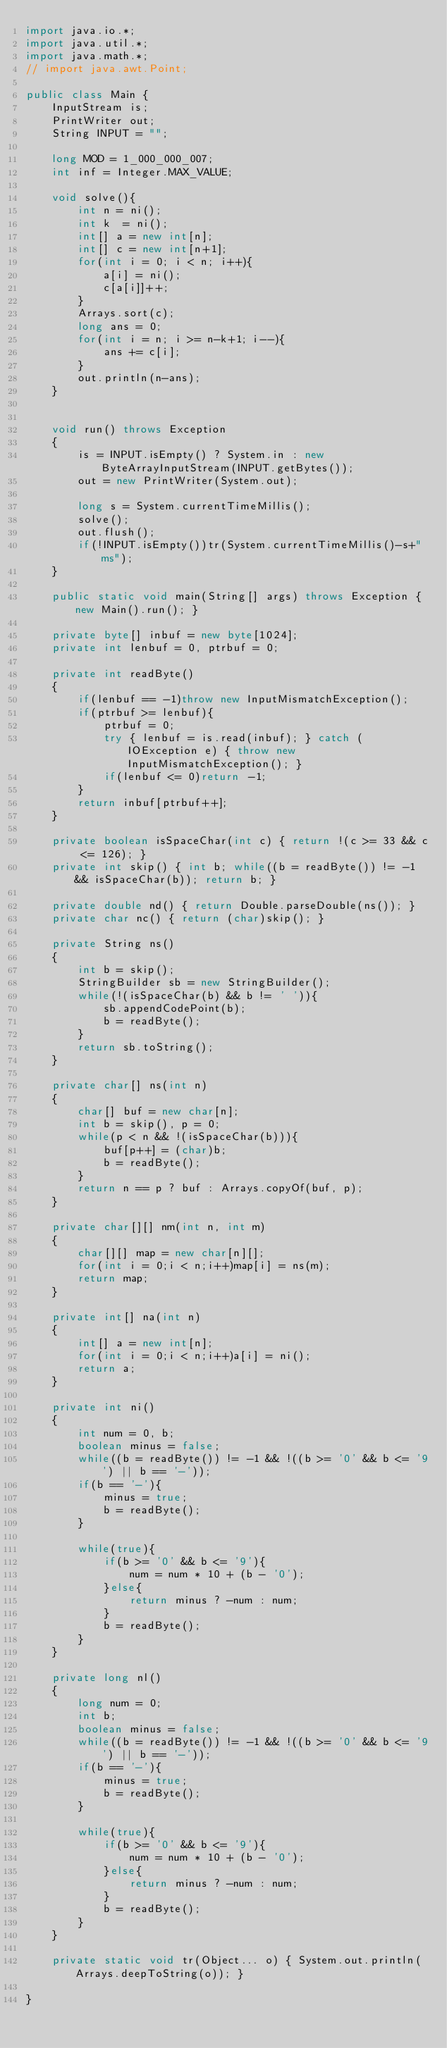<code> <loc_0><loc_0><loc_500><loc_500><_Java_>import java.io.*;
import java.util.*;
import java.math.*;
// import java.awt.Point;
 
public class Main {
    InputStream is;
    PrintWriter out;
    String INPUT = "";
 
    long MOD = 1_000_000_007;
    int inf = Integer.MAX_VALUE;

    void solve(){
        int n = ni();
        int k  = ni();
        int[] a = new int[n];
        int[] c = new int[n+1];
        for(int i = 0; i < n; i++){
            a[i] = ni();
            c[a[i]]++;
        }
        Arrays.sort(c);
        long ans = 0;
        for(int i = n; i >= n-k+1; i--){
            ans += c[i];
        }
        out.println(n-ans);
    }

    
    void run() throws Exception
    {
        is = INPUT.isEmpty() ? System.in : new ByteArrayInputStream(INPUT.getBytes());
        out = new PrintWriter(System.out);
        
        long s = System.currentTimeMillis();
        solve();
        out.flush();
        if(!INPUT.isEmpty())tr(System.currentTimeMillis()-s+"ms");
    }
    
    public static void main(String[] args) throws Exception { new Main().run(); }
    
    private byte[] inbuf = new byte[1024];
    private int lenbuf = 0, ptrbuf = 0;
    
    private int readByte()
    {
        if(lenbuf == -1)throw new InputMismatchException();
        if(ptrbuf >= lenbuf){
            ptrbuf = 0;
            try { lenbuf = is.read(inbuf); } catch (IOException e) { throw new InputMismatchException(); }
            if(lenbuf <= 0)return -1;
        }
        return inbuf[ptrbuf++];
    }
    
    private boolean isSpaceChar(int c) { return !(c >= 33 && c <= 126); }
    private int skip() { int b; while((b = readByte()) != -1 && isSpaceChar(b)); return b; }
    
    private double nd() { return Double.parseDouble(ns()); }
    private char nc() { return (char)skip(); }
    
    private String ns()
    {
        int b = skip();
        StringBuilder sb = new StringBuilder();
        while(!(isSpaceChar(b) && b != ' ')){
            sb.appendCodePoint(b);
            b = readByte();
        }
        return sb.toString();
    }
    
    private char[] ns(int n)
    {
        char[] buf = new char[n];
        int b = skip(), p = 0;
        while(p < n && !(isSpaceChar(b))){
            buf[p++] = (char)b;
            b = readByte();
        }
        return n == p ? buf : Arrays.copyOf(buf, p);
    }
    
    private char[][] nm(int n, int m)
    {
        char[][] map = new char[n][];
        for(int i = 0;i < n;i++)map[i] = ns(m);
        return map;
    }
    
    private int[] na(int n)
    {
        int[] a = new int[n];
        for(int i = 0;i < n;i++)a[i] = ni();
        return a;
    }
    
    private int ni()
    {
        int num = 0, b;
        boolean minus = false;
        while((b = readByte()) != -1 && !((b >= '0' && b <= '9') || b == '-'));
        if(b == '-'){
            minus = true;
            b = readByte();
        }
        
        while(true){
            if(b >= '0' && b <= '9'){
                num = num * 10 + (b - '0');
            }else{
                return minus ? -num : num;
            }
            b = readByte();
        }
    }
    
    private long nl()
    {
        long num = 0;
        int b;
        boolean minus = false;
        while((b = readByte()) != -1 && !((b >= '0' && b <= '9') || b == '-'));
        if(b == '-'){
            minus = true;
            b = readByte();
        }
        
        while(true){
            if(b >= '0' && b <= '9'){
                num = num * 10 + (b - '0');
            }else{
                return minus ? -num : num;
            }
            b = readByte();
        }
    }
    
    private static void tr(Object... o) { System.out.println(Arrays.deepToString(o)); }
 
}</code> 